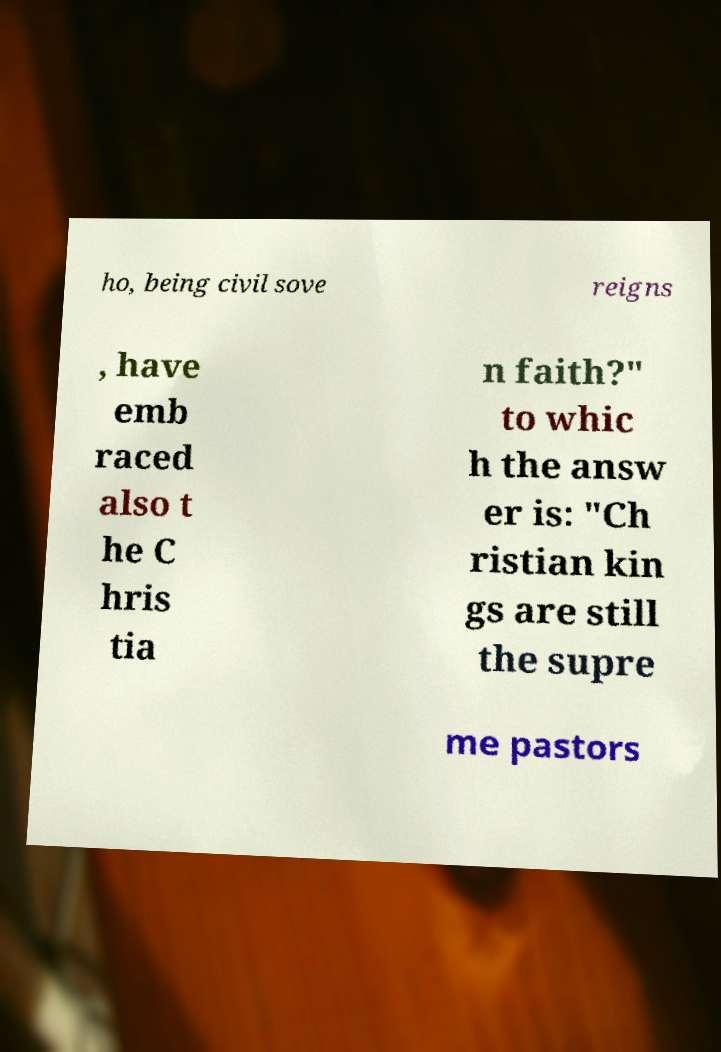Can you accurately transcribe the text from the provided image for me? ho, being civil sove reigns , have emb raced also t he C hris tia n faith?" to whic h the answ er is: "Ch ristian kin gs are still the supre me pastors 